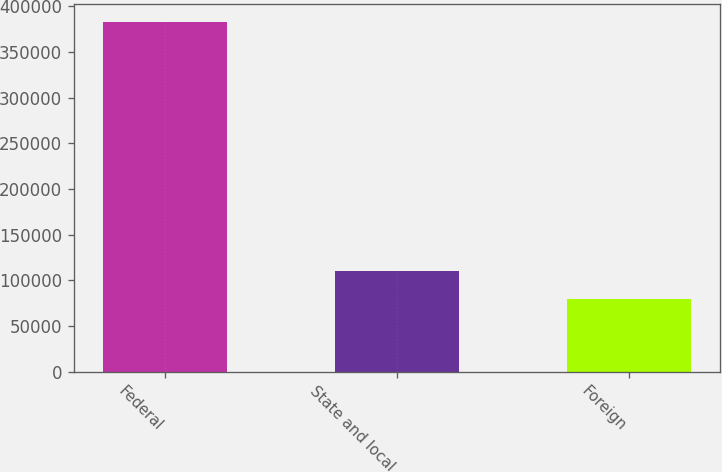Convert chart to OTSL. <chart><loc_0><loc_0><loc_500><loc_500><bar_chart><fcel>Federal<fcel>State and local<fcel>Foreign<nl><fcel>382925<fcel>110147<fcel>79838<nl></chart> 